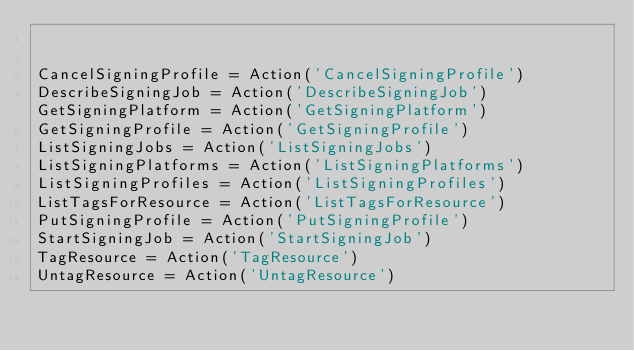Convert code to text. <code><loc_0><loc_0><loc_500><loc_500><_Python_>

CancelSigningProfile = Action('CancelSigningProfile')
DescribeSigningJob = Action('DescribeSigningJob')
GetSigningPlatform = Action('GetSigningPlatform')
GetSigningProfile = Action('GetSigningProfile')
ListSigningJobs = Action('ListSigningJobs')
ListSigningPlatforms = Action('ListSigningPlatforms')
ListSigningProfiles = Action('ListSigningProfiles')
ListTagsForResource = Action('ListTagsForResource')
PutSigningProfile = Action('PutSigningProfile')
StartSigningJob = Action('StartSigningJob')
TagResource = Action('TagResource')
UntagResource = Action('UntagResource')
</code> 